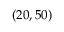Convert formula to latex. <formula><loc_0><loc_0><loc_500><loc_500>( 2 0 , 5 0 )</formula> 